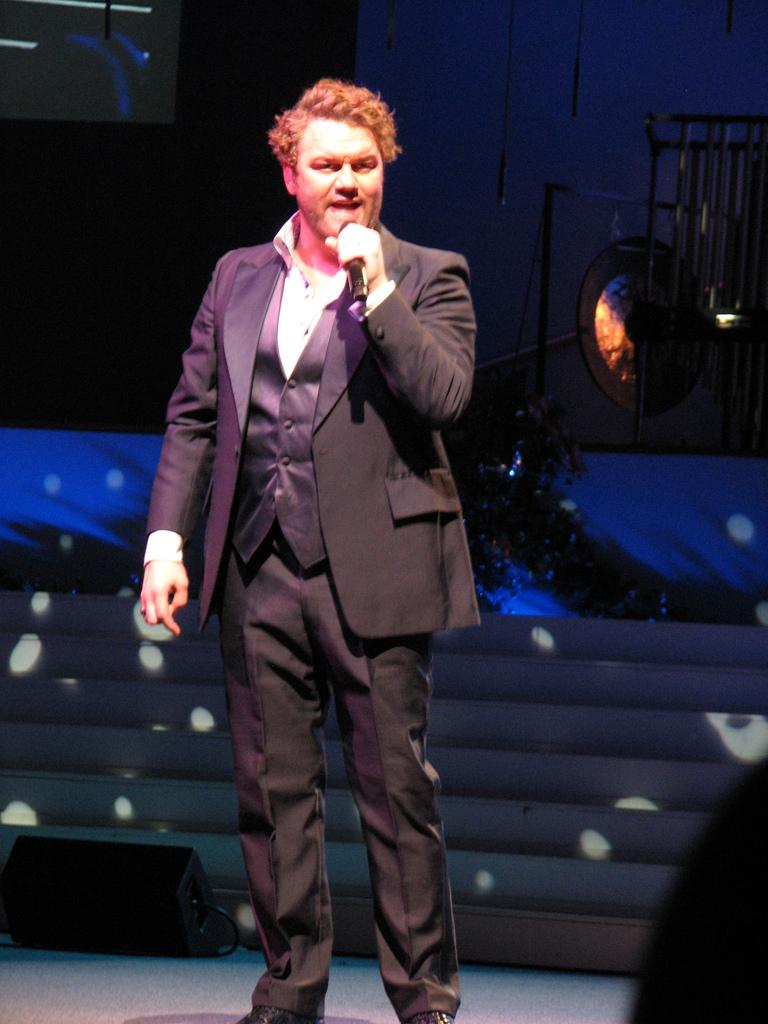What is the man in the image doing? The man is standing and speaking in the image. What is the man holding in the image? The man is holding a microphone in the image. What is the man wearing in the image? The man is wearing a suit in the image. What can be seen in the background of the image? There is a cymbal-like object in the background of the image. How many ants are crawling on the man's suit in the image? There are no ants visible on the man's suit in the image. What wish does the man make while speaking in the image? There is no information about the man making a wish while speaking in the image. 